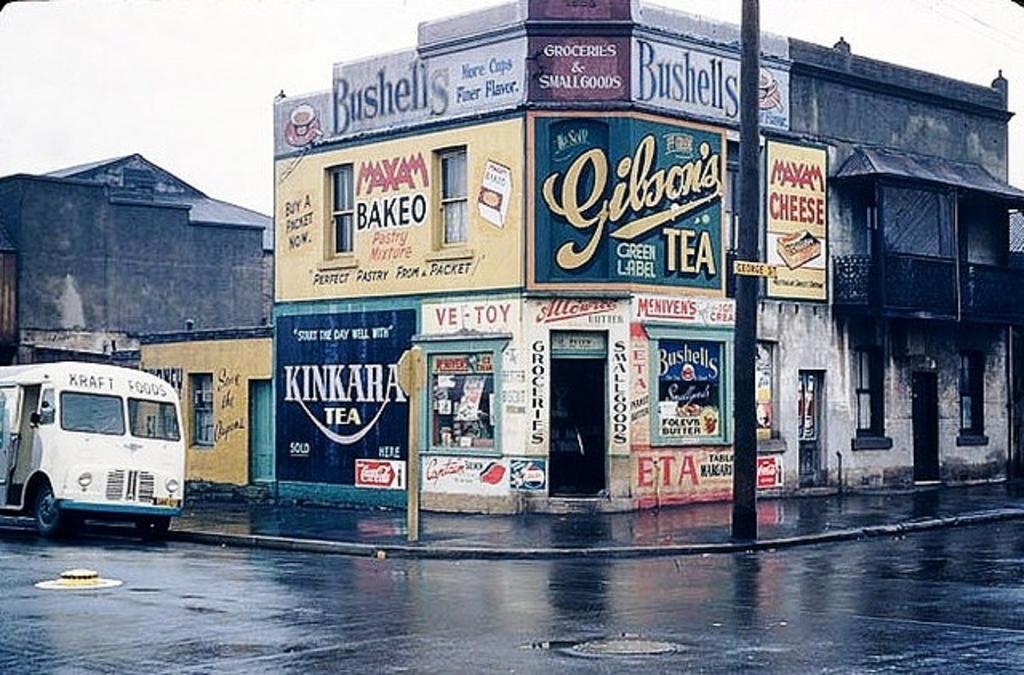In one or two sentences, can you explain what this image depicts? In this image there is the sky, there is a building, there is text on the building, there is a pole, there is a board, there is a building truncated towards the left of the image, there is a vehicle truncated towards the left of the image, there is a road, there is the door, there are windows. 